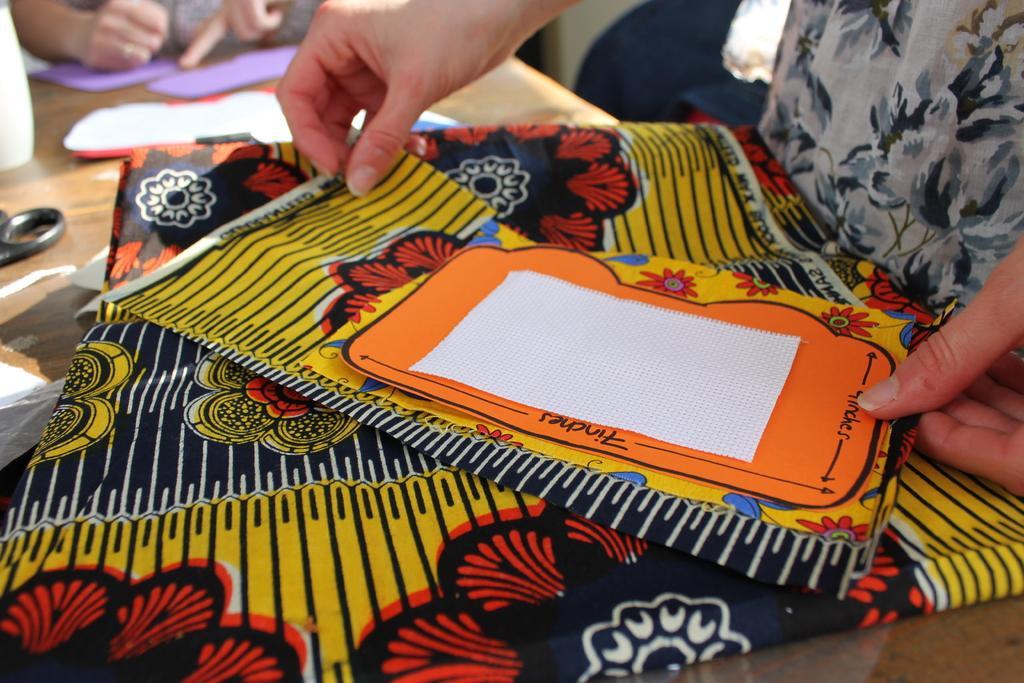In one or two sentences, can you explain what this image depicts? In this image there is a cloth in the middle. On the right side there is a person holding the cloth with the hands. The cloth is on the table. On the table there is a scissor and papers on it. On the left side top there is a person who is drawing on the paper. 